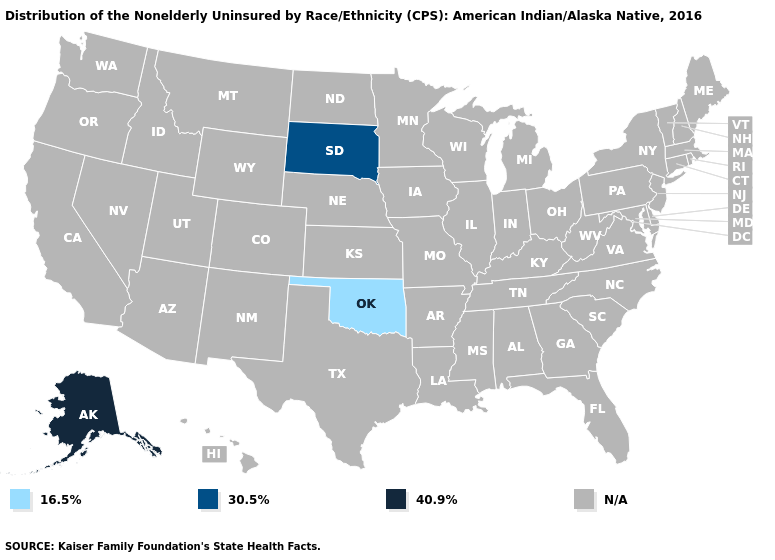What is the lowest value in the West?
Answer briefly. 40.9%. Which states have the lowest value in the USA?
Quick response, please. Oklahoma. What is the value of Hawaii?
Keep it brief. N/A. What is the value of North Dakota?
Short answer required. N/A. Is the legend a continuous bar?
Be succinct. No. Name the states that have a value in the range 40.9%?
Write a very short answer. Alaska. What is the value of Connecticut?
Short answer required. N/A. Does the first symbol in the legend represent the smallest category?
Answer briefly. Yes. Which states have the lowest value in the South?
Keep it brief. Oklahoma. 